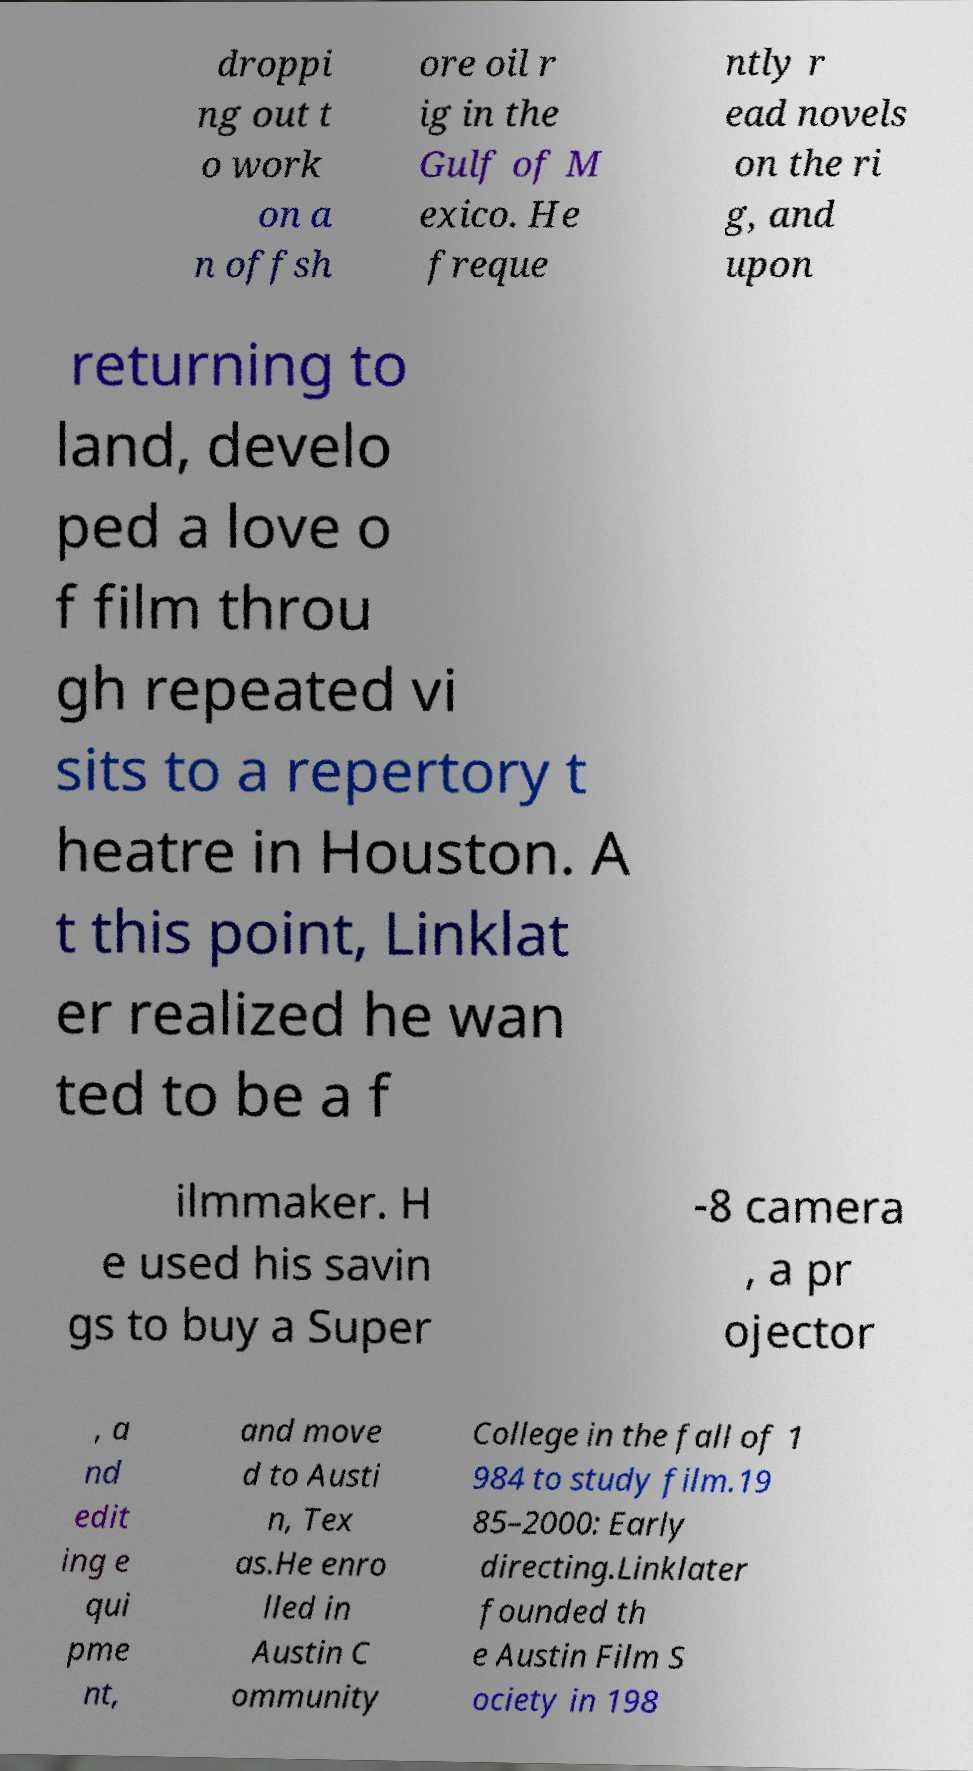There's text embedded in this image that I need extracted. Can you transcribe it verbatim? droppi ng out t o work on a n offsh ore oil r ig in the Gulf of M exico. He freque ntly r ead novels on the ri g, and upon returning to land, develo ped a love o f film throu gh repeated vi sits to a repertory t heatre in Houston. A t this point, Linklat er realized he wan ted to be a f ilmmaker. H e used his savin gs to buy a Super -8 camera , a pr ojector , a nd edit ing e qui pme nt, and move d to Austi n, Tex as.He enro lled in Austin C ommunity College in the fall of 1 984 to study film.19 85–2000: Early directing.Linklater founded th e Austin Film S ociety in 198 